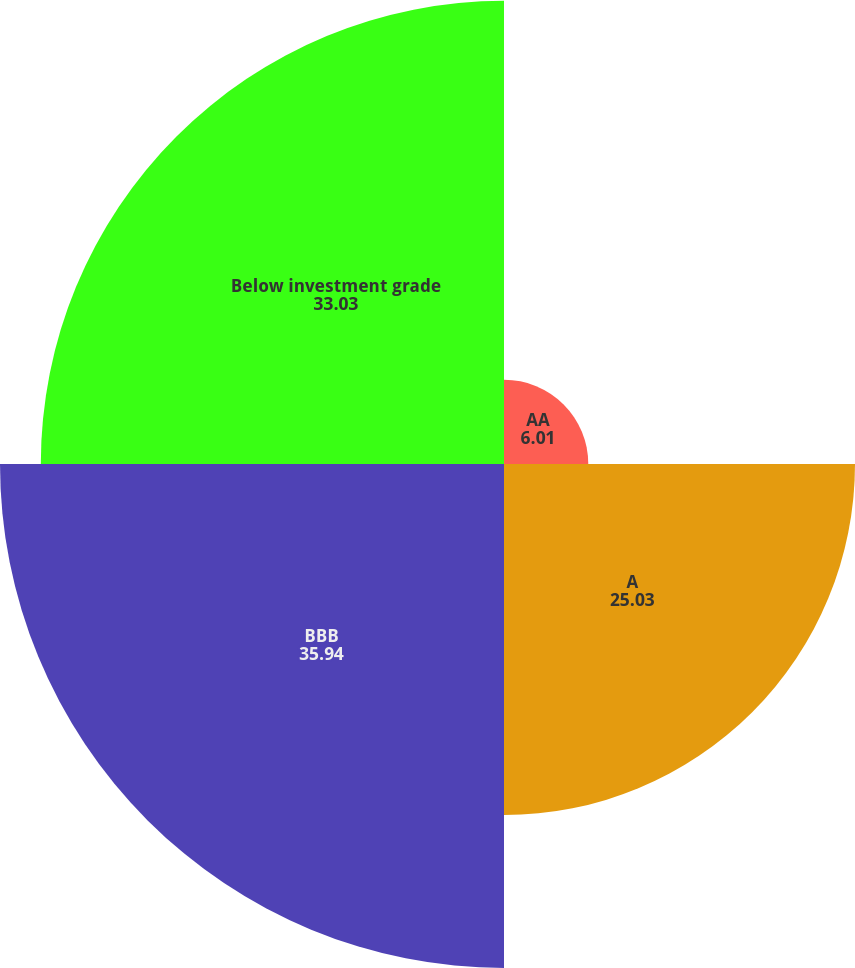Convert chart to OTSL. <chart><loc_0><loc_0><loc_500><loc_500><pie_chart><fcel>AA<fcel>A<fcel>BBB<fcel>Below investment grade<nl><fcel>6.01%<fcel>25.03%<fcel>35.94%<fcel>33.03%<nl></chart> 